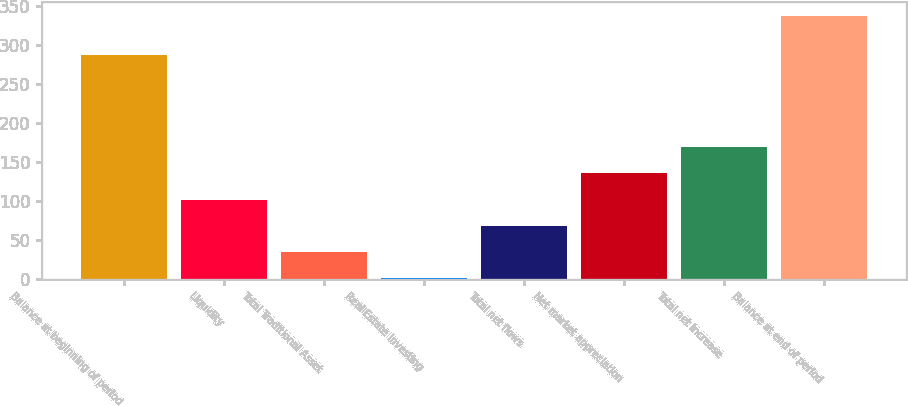Convert chart to OTSL. <chart><loc_0><loc_0><loc_500><loc_500><bar_chart><fcel>Balance at beginning of period<fcel>Liquidity<fcel>Total Traditional Asset<fcel>Real Estate Investing<fcel>Total net flows<fcel>Net market appreciation<fcel>Total net increase<fcel>Balance at end of period<nl><fcel>287<fcel>102.1<fcel>34.7<fcel>1<fcel>68.4<fcel>135.8<fcel>169.5<fcel>338<nl></chart> 